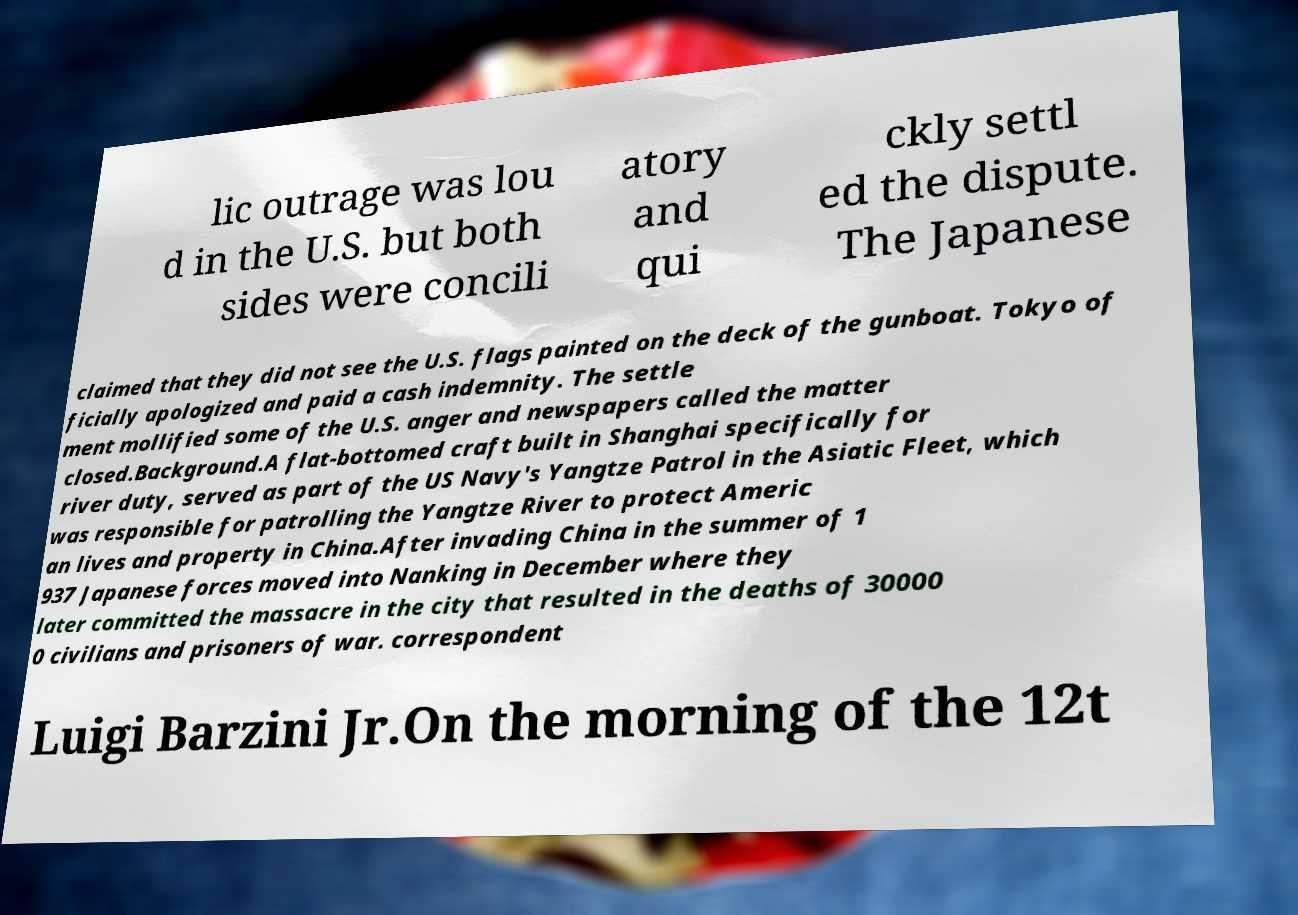Can you read and provide the text displayed in the image?This photo seems to have some interesting text. Can you extract and type it out for me? lic outrage was lou d in the U.S. but both sides were concili atory and qui ckly settl ed the dispute. The Japanese claimed that they did not see the U.S. flags painted on the deck of the gunboat. Tokyo of ficially apologized and paid a cash indemnity. The settle ment mollified some of the U.S. anger and newspapers called the matter closed.Background.A flat-bottomed craft built in Shanghai specifically for river duty, served as part of the US Navy's Yangtze Patrol in the Asiatic Fleet, which was responsible for patrolling the Yangtze River to protect Americ an lives and property in China.After invading China in the summer of 1 937 Japanese forces moved into Nanking in December where they later committed the massacre in the city that resulted in the deaths of 30000 0 civilians and prisoners of war. correspondent Luigi Barzini Jr.On the morning of the 12t 